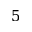<formula> <loc_0><loc_0><loc_500><loc_500>5</formula> 